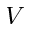<formula> <loc_0><loc_0><loc_500><loc_500>V</formula> 